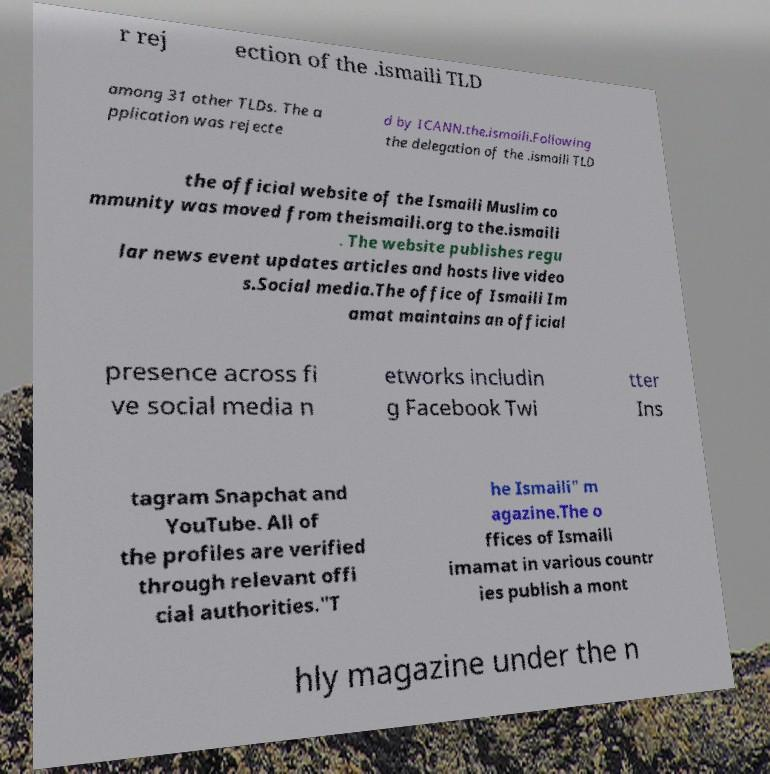Please read and relay the text visible in this image. What does it say? r rej ection of the .ismaili TLD among 31 other TLDs. The a pplication was rejecte d by ICANN.the.ismaili.Following the delegation of the .ismaili TLD the official website of the Ismaili Muslim co mmunity was moved from theismaili.org to the.ismaili . The website publishes regu lar news event updates articles and hosts live video s.Social media.The office of Ismaili Im amat maintains an official presence across fi ve social media n etworks includin g Facebook Twi tter Ins tagram Snapchat and YouTube. All of the profiles are verified through relevant offi cial authorities."T he Ismaili" m agazine.The o ffices of Ismaili imamat in various countr ies publish a mont hly magazine under the n 